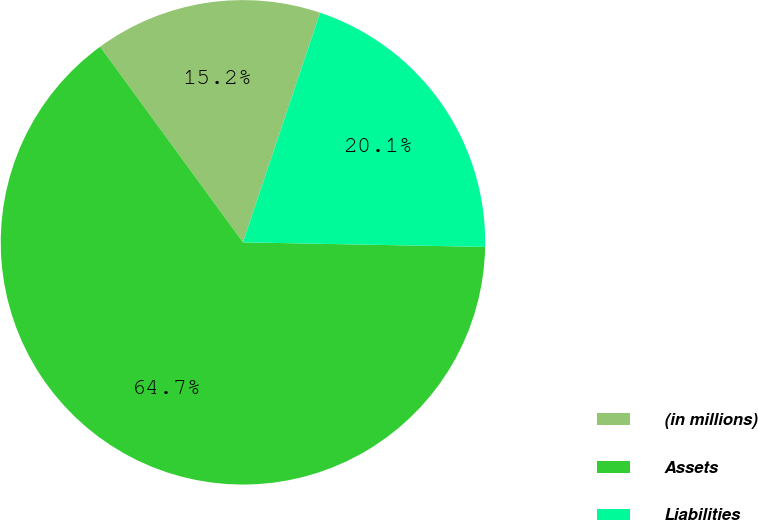<chart> <loc_0><loc_0><loc_500><loc_500><pie_chart><fcel>(in millions)<fcel>Assets<fcel>Liabilities<nl><fcel>15.2%<fcel>64.66%<fcel>20.14%<nl></chart> 